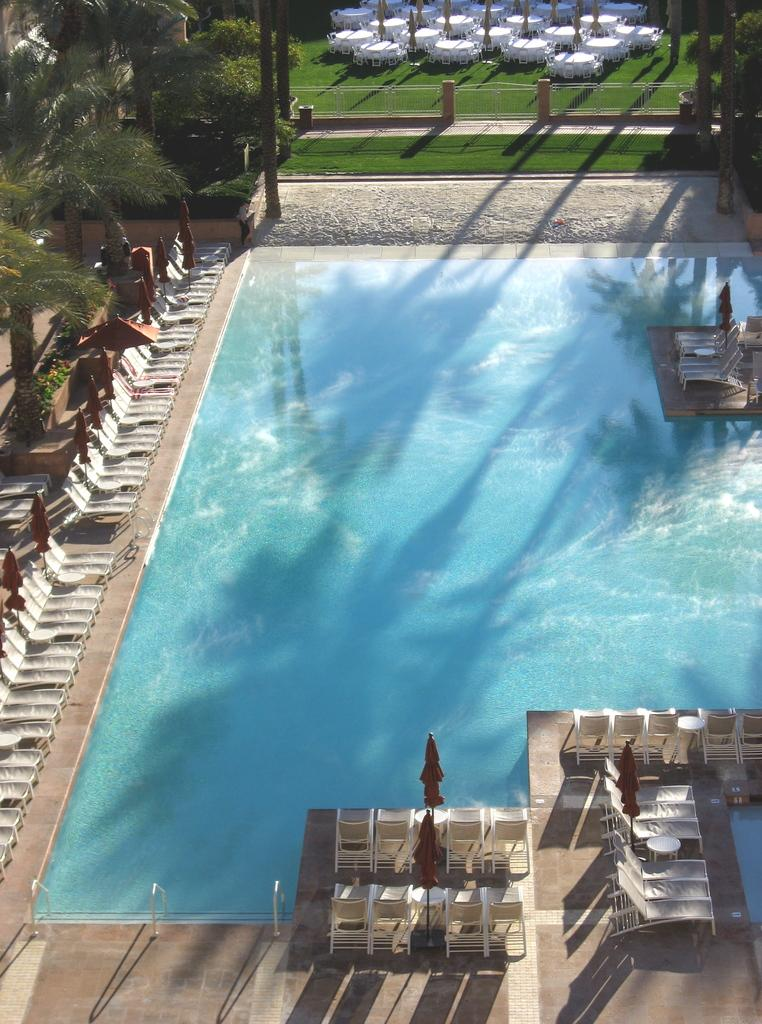What is visible in the image? Water is visible in the image. What can be seen in the background of the image? There are trees and objects in the background of the image. What is the color of the trees in the image? The trees are green in color. What is the color of the objects in the background of the image? The objects are white in color. Can you see a fireman wearing a scarf in the image? There is no fireman or scarf present in the image. 